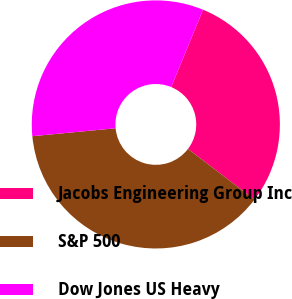Convert chart. <chart><loc_0><loc_0><loc_500><loc_500><pie_chart><fcel>Jacobs Engineering Group Inc<fcel>S&P 500<fcel>Dow Jones US Heavy<nl><fcel>29.15%<fcel>38.13%<fcel>32.72%<nl></chart> 